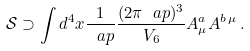Convert formula to latex. <formula><loc_0><loc_0><loc_500><loc_500>\mathcal { S } \supset \int d ^ { 4 } x \frac { 1 } { \ a p } \frac { ( 2 \pi \ a p ) ^ { 3 } } { V _ { 6 } } A _ { \mu } ^ { a } A ^ { b \, \mu } \, .</formula> 